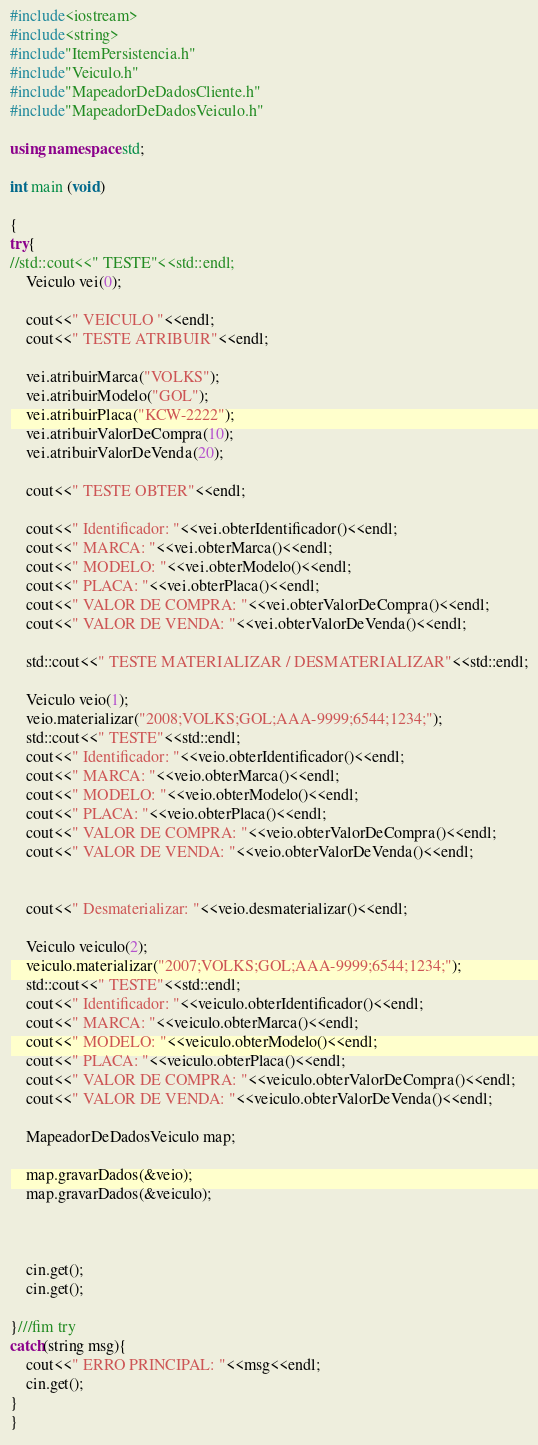Convert code to text. <code><loc_0><loc_0><loc_500><loc_500><_C++_>#include<iostream>
#include<string>
#include"ItemPersistencia.h"
#include"Veiculo.h"
#include"MapeadorDeDadosCliente.h"
#include"MapeadorDeDadosVeiculo.h"

using namespace std;

int main (void)

{
try{
//std::cout<<" TESTE"<<std::endl;	
	Veiculo vei(0);
	
	cout<<" VEICULO "<<endl;
	cout<<" TESTE ATRIBUIR"<<endl;
	
	vei.atribuirMarca("VOLKS");
	vei.atribuirModelo("GOL");
	vei.atribuirPlaca("KCW-2222");
	vei.atribuirValorDeCompra(10);
	vei.atribuirValorDeVenda(20);

	cout<<" TESTE OBTER"<<endl;

	cout<<" Identificador: "<<vei.obterIdentificador()<<endl; 	
	cout<<" MARCA: "<<vei.obterMarca()<<endl;
	cout<<" MODELO: "<<vei.obterModelo()<<endl;
	cout<<" PLACA: "<<vei.obterPlaca()<<endl;
	cout<<" VALOR DE COMPRA: "<<vei.obterValorDeCompra()<<endl;
	cout<<" VALOR DE VENDA: "<<vei.obterValorDeVenda()<<endl;
	
	std::cout<<" TESTE MATERIALIZAR / DESMATERIALIZAR"<<std::endl;
	
	Veiculo veio(1);
	veio.materializar("2008;VOLKS;GOL;AAA-9999;6544;1234;");
	std::cout<<" TESTE"<<std::endl;	
	cout<<" Identificador: "<<veio.obterIdentificador()<<endl; 	
	cout<<" MARCA: "<<veio.obterMarca()<<endl;
	cout<<" MODELO: "<<veio.obterModelo()<<endl;
	cout<<" PLACA: "<<veio.obterPlaca()<<endl;
	cout<<" VALOR DE COMPRA: "<<veio.obterValorDeCompra()<<endl;
	cout<<" VALOR DE VENDA: "<<veio.obterValorDeVenda()<<endl;
	
	
	cout<<" Desmaterializar: "<<veio.desmaterializar()<<endl;
	
	Veiculo veiculo(2);
	veiculo.materializar("2007;VOLKS;GOL;AAA-9999;6544;1234;");
	std::cout<<" TESTE"<<std::endl;	
	cout<<" Identificador: "<<veiculo.obterIdentificador()<<endl; 	
	cout<<" MARCA: "<<veiculo.obterMarca()<<endl;
	cout<<" MODELO: "<<veiculo.obterModelo()<<endl;
	cout<<" PLACA: "<<veiculo.obterPlaca()<<endl;
	cout<<" VALOR DE COMPRA: "<<veiculo.obterValorDeCompra()<<endl;
	cout<<" VALOR DE VENDA: "<<veiculo.obterValorDeVenda()<<endl;
	
	MapeadorDeDadosVeiculo map;
	
	map.gravarDados(&veio);
	map.gravarDados(&veiculo);
	
	
	
	cin.get();
	cin.get();

}///fim try
catch(string msg){
	cout<<" ERRO PRINCIPAL: "<<msg<<endl;	
	cin.get();	
}
}
</code> 